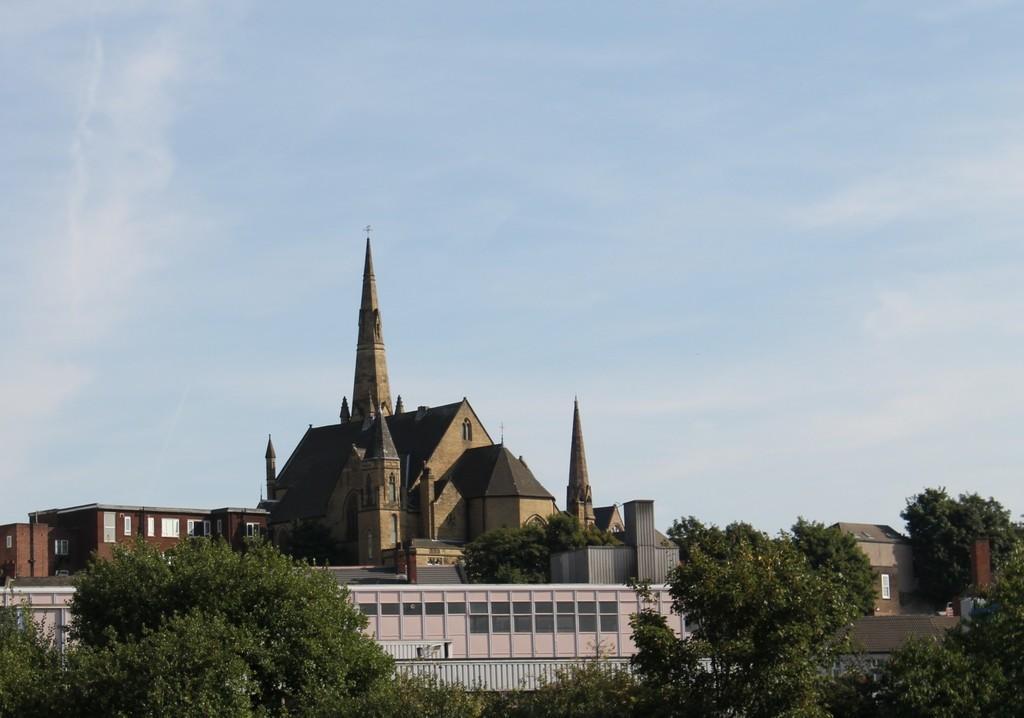Please provide a concise description of this image. In the foreground of the image we can see trees. In the middle of the image we can see buildings. On the top of the image we can see the sky. 